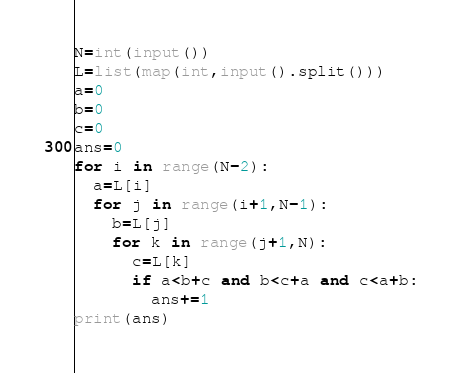<code> <loc_0><loc_0><loc_500><loc_500><_Python_>N=int(input())
L=list(map(int,input().split()))
a=0
b=0
c=0
ans=0
for i in range(N-2):
  a=L[i]
  for j in range(i+1,N-1):
    b=L[j]
    for k in range(j+1,N):
      c=L[k]
      if a<b+c and b<c+a and c<a+b:
        ans+=1
print(ans)</code> 